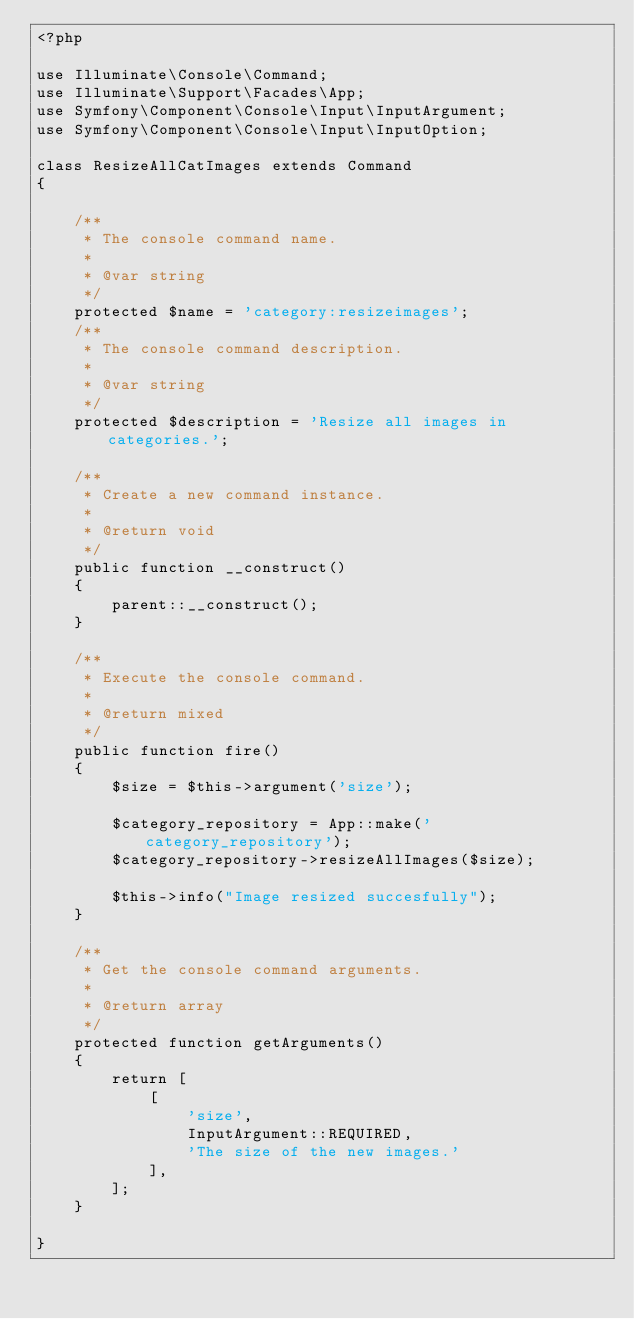<code> <loc_0><loc_0><loc_500><loc_500><_PHP_><?php

use Illuminate\Console\Command;
use Illuminate\Support\Facades\App;
use Symfony\Component\Console\Input\InputArgument;
use Symfony\Component\Console\Input\InputOption;

class ResizeAllCatImages extends Command
{

    /**
     * The console command name.
     *
     * @var string
     */
    protected $name = 'category:resizeimages';
    /**
     * The console command description.
     *
     * @var string
     */
    protected $description = 'Resize all images in categories.';

    /**
     * Create a new command instance.
     *
     * @return void
     */
    public function __construct()
    {
        parent::__construct();
    }

    /**
     * Execute the console command.
     *
     * @return mixed
     */
    public function fire()
    {
        $size = $this->argument('size');

        $category_repository = App::make('category_repository');
        $category_repository->resizeAllImages($size);

        $this->info("Image resized succesfully");
    }

    /**
     * Get the console command arguments.
     *
     * @return array
     */
    protected function getArguments()
    {
        return [
            [
                'size',
                InputArgument::REQUIRED,
                'The size of the new images.'
            ],
        ];
    }

}
</code> 